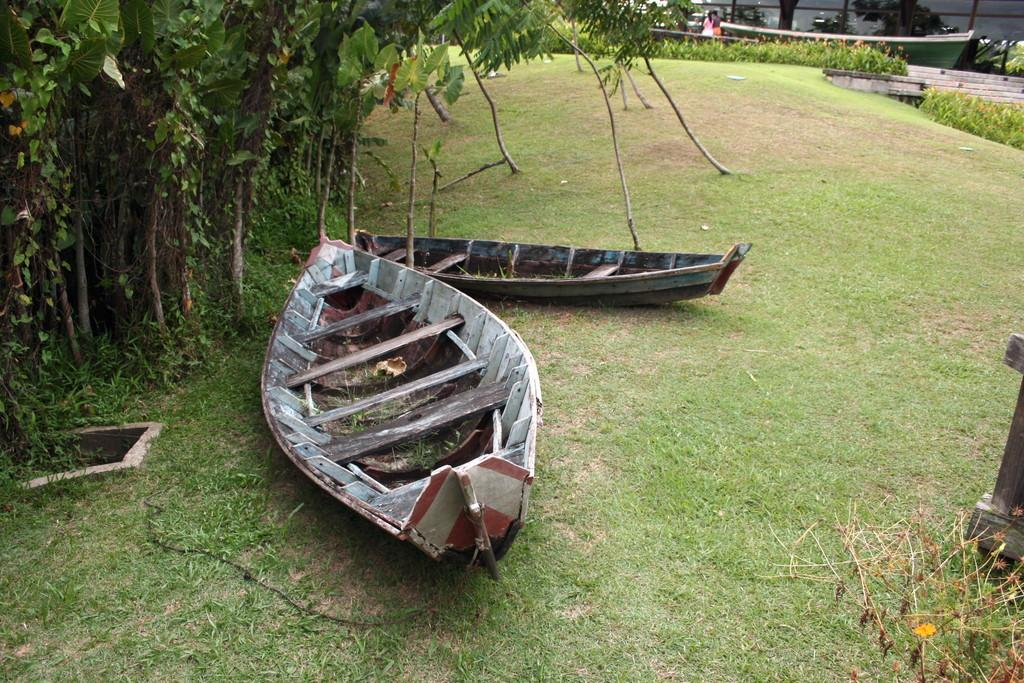What objects are placed on the grass in the image? There are boats on the grass in the image. What type of vegetation is located near the boats? Trees are located beside the boats. Can you describe the people visible in the background of the image? Unfortunately, the facts provided do not give enough information to describe the people in the background. Where is the store located in the image? There is no store present in the image. How many zebras can be seen grazing near the boats? There are no zebras present in the image. 